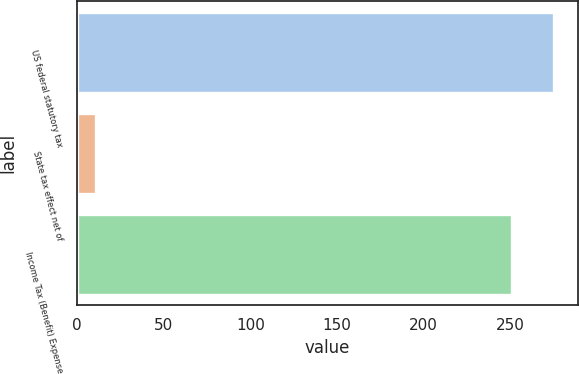Convert chart. <chart><loc_0><loc_0><loc_500><loc_500><bar_chart><fcel>US federal statutory tax<fcel>State tax effect net of<fcel>Income Tax (Benefit) Expense<nl><fcel>275.2<fcel>11<fcel>251<nl></chart> 